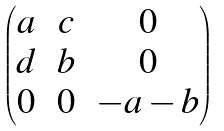Convert formula to latex. <formula><loc_0><loc_0><loc_500><loc_500>\begin{pmatrix} a \, & c \, & 0 \\ d \, & b \, & 0 \\ 0 \, & 0 \, & - a - b \end{pmatrix}</formula> 